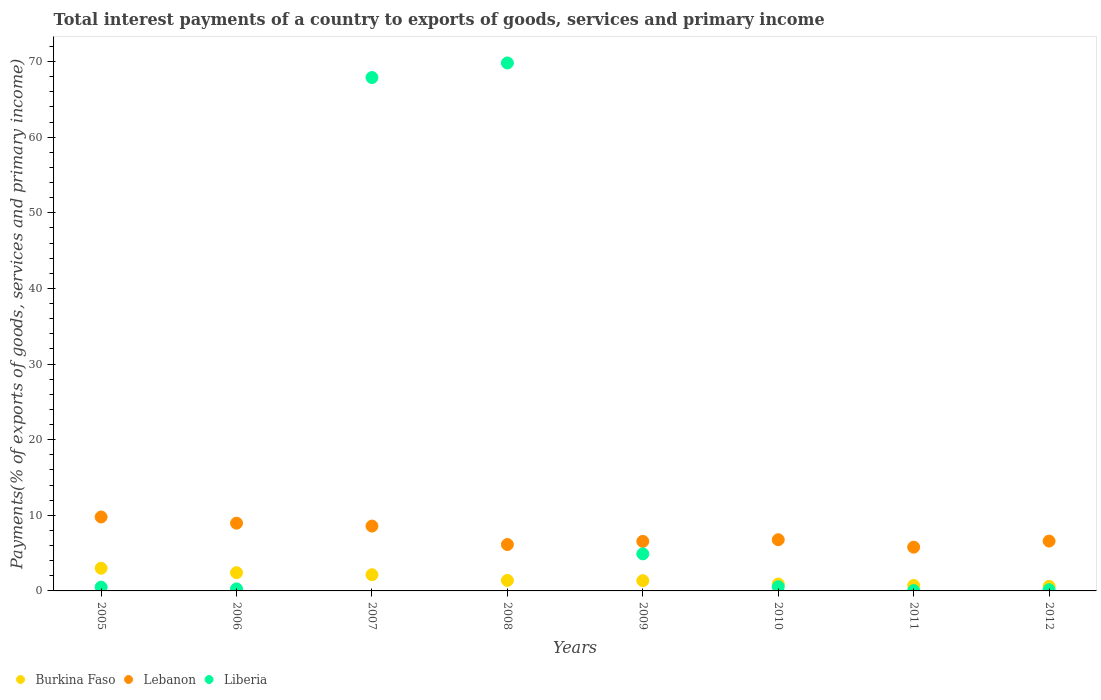How many different coloured dotlines are there?
Your answer should be very brief. 3. What is the total interest payments in Liberia in 2012?
Offer a terse response. 0.16. Across all years, what is the maximum total interest payments in Liberia?
Keep it short and to the point. 69.81. Across all years, what is the minimum total interest payments in Burkina Faso?
Make the answer very short. 0.6. In which year was the total interest payments in Liberia maximum?
Provide a succinct answer. 2008. In which year was the total interest payments in Lebanon minimum?
Ensure brevity in your answer.  2011. What is the total total interest payments in Lebanon in the graph?
Give a very brief answer. 59.14. What is the difference between the total interest payments in Liberia in 2007 and that in 2011?
Keep it short and to the point. 67.84. What is the difference between the total interest payments in Burkina Faso in 2006 and the total interest payments in Lebanon in 2005?
Your response must be concise. -7.37. What is the average total interest payments in Liberia per year?
Keep it short and to the point. 18.02. In the year 2005, what is the difference between the total interest payments in Lebanon and total interest payments in Liberia?
Ensure brevity in your answer.  9.27. In how many years, is the total interest payments in Lebanon greater than 50 %?
Ensure brevity in your answer.  0. What is the ratio of the total interest payments in Liberia in 2006 to that in 2009?
Your answer should be compact. 0.05. Is the total interest payments in Liberia in 2005 less than that in 2011?
Your response must be concise. No. Is the difference between the total interest payments in Lebanon in 2006 and 2008 greater than the difference between the total interest payments in Liberia in 2006 and 2008?
Offer a terse response. Yes. What is the difference between the highest and the second highest total interest payments in Liberia?
Ensure brevity in your answer.  1.93. What is the difference between the highest and the lowest total interest payments in Lebanon?
Your response must be concise. 3.99. In how many years, is the total interest payments in Liberia greater than the average total interest payments in Liberia taken over all years?
Give a very brief answer. 2. Is the sum of the total interest payments in Burkina Faso in 2010 and 2012 greater than the maximum total interest payments in Liberia across all years?
Provide a short and direct response. No. Does the total interest payments in Lebanon monotonically increase over the years?
Offer a terse response. No. Is the total interest payments in Liberia strictly greater than the total interest payments in Lebanon over the years?
Make the answer very short. No. How many years are there in the graph?
Offer a very short reply. 8. What is the difference between two consecutive major ticks on the Y-axis?
Ensure brevity in your answer.  10. Are the values on the major ticks of Y-axis written in scientific E-notation?
Your answer should be very brief. No. Where does the legend appear in the graph?
Your response must be concise. Bottom left. What is the title of the graph?
Provide a succinct answer. Total interest payments of a country to exports of goods, services and primary income. What is the label or title of the X-axis?
Your response must be concise. Years. What is the label or title of the Y-axis?
Provide a succinct answer. Payments(% of exports of goods, services and primary income). What is the Payments(% of exports of goods, services and primary income) of Burkina Faso in 2005?
Offer a very short reply. 3. What is the Payments(% of exports of goods, services and primary income) in Lebanon in 2005?
Your answer should be very brief. 9.78. What is the Payments(% of exports of goods, services and primary income) in Liberia in 2005?
Your answer should be compact. 0.5. What is the Payments(% of exports of goods, services and primary income) of Burkina Faso in 2006?
Your answer should be compact. 2.41. What is the Payments(% of exports of goods, services and primary income) in Lebanon in 2006?
Provide a short and direct response. 8.96. What is the Payments(% of exports of goods, services and primary income) of Liberia in 2006?
Provide a succinct answer. 0.27. What is the Payments(% of exports of goods, services and primary income) of Burkina Faso in 2007?
Keep it short and to the point. 2.14. What is the Payments(% of exports of goods, services and primary income) in Lebanon in 2007?
Offer a terse response. 8.58. What is the Payments(% of exports of goods, services and primary income) of Liberia in 2007?
Your answer should be compact. 67.89. What is the Payments(% of exports of goods, services and primary income) in Burkina Faso in 2008?
Keep it short and to the point. 1.39. What is the Payments(% of exports of goods, services and primary income) of Lebanon in 2008?
Make the answer very short. 6.13. What is the Payments(% of exports of goods, services and primary income) of Liberia in 2008?
Provide a short and direct response. 69.81. What is the Payments(% of exports of goods, services and primary income) of Burkina Faso in 2009?
Make the answer very short. 1.36. What is the Payments(% of exports of goods, services and primary income) of Lebanon in 2009?
Your answer should be very brief. 6.55. What is the Payments(% of exports of goods, services and primary income) in Liberia in 2009?
Keep it short and to the point. 4.9. What is the Payments(% of exports of goods, services and primary income) in Burkina Faso in 2010?
Your response must be concise. 0.91. What is the Payments(% of exports of goods, services and primary income) of Lebanon in 2010?
Offer a very short reply. 6.77. What is the Payments(% of exports of goods, services and primary income) of Liberia in 2010?
Your answer should be compact. 0.56. What is the Payments(% of exports of goods, services and primary income) of Burkina Faso in 2011?
Your response must be concise. 0.72. What is the Payments(% of exports of goods, services and primary income) in Lebanon in 2011?
Make the answer very short. 5.79. What is the Payments(% of exports of goods, services and primary income) in Liberia in 2011?
Provide a short and direct response. 0.05. What is the Payments(% of exports of goods, services and primary income) in Burkina Faso in 2012?
Your answer should be very brief. 0.6. What is the Payments(% of exports of goods, services and primary income) of Lebanon in 2012?
Keep it short and to the point. 6.59. What is the Payments(% of exports of goods, services and primary income) of Liberia in 2012?
Your answer should be very brief. 0.16. Across all years, what is the maximum Payments(% of exports of goods, services and primary income) in Burkina Faso?
Make the answer very short. 3. Across all years, what is the maximum Payments(% of exports of goods, services and primary income) of Lebanon?
Your answer should be compact. 9.78. Across all years, what is the maximum Payments(% of exports of goods, services and primary income) in Liberia?
Give a very brief answer. 69.81. Across all years, what is the minimum Payments(% of exports of goods, services and primary income) in Burkina Faso?
Provide a succinct answer. 0.6. Across all years, what is the minimum Payments(% of exports of goods, services and primary income) of Lebanon?
Your response must be concise. 5.79. Across all years, what is the minimum Payments(% of exports of goods, services and primary income) in Liberia?
Your answer should be compact. 0.05. What is the total Payments(% of exports of goods, services and primary income) in Burkina Faso in the graph?
Offer a very short reply. 12.53. What is the total Payments(% of exports of goods, services and primary income) in Lebanon in the graph?
Provide a short and direct response. 59.14. What is the total Payments(% of exports of goods, services and primary income) of Liberia in the graph?
Keep it short and to the point. 144.14. What is the difference between the Payments(% of exports of goods, services and primary income) in Burkina Faso in 2005 and that in 2006?
Ensure brevity in your answer.  0.59. What is the difference between the Payments(% of exports of goods, services and primary income) of Lebanon in 2005 and that in 2006?
Give a very brief answer. 0.82. What is the difference between the Payments(% of exports of goods, services and primary income) of Liberia in 2005 and that in 2006?
Your response must be concise. 0.24. What is the difference between the Payments(% of exports of goods, services and primary income) in Burkina Faso in 2005 and that in 2007?
Your response must be concise. 0.86. What is the difference between the Payments(% of exports of goods, services and primary income) of Lebanon in 2005 and that in 2007?
Your answer should be compact. 1.2. What is the difference between the Payments(% of exports of goods, services and primary income) in Liberia in 2005 and that in 2007?
Your response must be concise. -67.38. What is the difference between the Payments(% of exports of goods, services and primary income) in Burkina Faso in 2005 and that in 2008?
Your answer should be compact. 1.61. What is the difference between the Payments(% of exports of goods, services and primary income) of Lebanon in 2005 and that in 2008?
Your answer should be very brief. 3.64. What is the difference between the Payments(% of exports of goods, services and primary income) of Liberia in 2005 and that in 2008?
Ensure brevity in your answer.  -69.31. What is the difference between the Payments(% of exports of goods, services and primary income) in Burkina Faso in 2005 and that in 2009?
Your answer should be compact. 1.64. What is the difference between the Payments(% of exports of goods, services and primary income) in Lebanon in 2005 and that in 2009?
Offer a terse response. 3.23. What is the difference between the Payments(% of exports of goods, services and primary income) in Liberia in 2005 and that in 2009?
Offer a terse response. -4.4. What is the difference between the Payments(% of exports of goods, services and primary income) in Burkina Faso in 2005 and that in 2010?
Make the answer very short. 2.09. What is the difference between the Payments(% of exports of goods, services and primary income) in Lebanon in 2005 and that in 2010?
Your response must be concise. 3.01. What is the difference between the Payments(% of exports of goods, services and primary income) of Liberia in 2005 and that in 2010?
Make the answer very short. -0.06. What is the difference between the Payments(% of exports of goods, services and primary income) of Burkina Faso in 2005 and that in 2011?
Offer a terse response. 2.28. What is the difference between the Payments(% of exports of goods, services and primary income) in Lebanon in 2005 and that in 2011?
Keep it short and to the point. 3.99. What is the difference between the Payments(% of exports of goods, services and primary income) of Liberia in 2005 and that in 2011?
Your response must be concise. 0.45. What is the difference between the Payments(% of exports of goods, services and primary income) in Burkina Faso in 2005 and that in 2012?
Your answer should be very brief. 2.4. What is the difference between the Payments(% of exports of goods, services and primary income) of Lebanon in 2005 and that in 2012?
Your answer should be compact. 3.19. What is the difference between the Payments(% of exports of goods, services and primary income) of Liberia in 2005 and that in 2012?
Provide a succinct answer. 0.34. What is the difference between the Payments(% of exports of goods, services and primary income) in Burkina Faso in 2006 and that in 2007?
Your answer should be very brief. 0.27. What is the difference between the Payments(% of exports of goods, services and primary income) in Lebanon in 2006 and that in 2007?
Your response must be concise. 0.38. What is the difference between the Payments(% of exports of goods, services and primary income) in Liberia in 2006 and that in 2007?
Your answer should be compact. -67.62. What is the difference between the Payments(% of exports of goods, services and primary income) of Burkina Faso in 2006 and that in 2008?
Keep it short and to the point. 1.02. What is the difference between the Payments(% of exports of goods, services and primary income) of Lebanon in 2006 and that in 2008?
Your answer should be compact. 2.82. What is the difference between the Payments(% of exports of goods, services and primary income) in Liberia in 2006 and that in 2008?
Your response must be concise. -69.55. What is the difference between the Payments(% of exports of goods, services and primary income) of Burkina Faso in 2006 and that in 2009?
Provide a short and direct response. 1.05. What is the difference between the Payments(% of exports of goods, services and primary income) in Lebanon in 2006 and that in 2009?
Ensure brevity in your answer.  2.41. What is the difference between the Payments(% of exports of goods, services and primary income) of Liberia in 2006 and that in 2009?
Offer a terse response. -4.63. What is the difference between the Payments(% of exports of goods, services and primary income) of Burkina Faso in 2006 and that in 2010?
Make the answer very short. 1.5. What is the difference between the Payments(% of exports of goods, services and primary income) in Lebanon in 2006 and that in 2010?
Keep it short and to the point. 2.19. What is the difference between the Payments(% of exports of goods, services and primary income) in Liberia in 2006 and that in 2010?
Ensure brevity in your answer.  -0.29. What is the difference between the Payments(% of exports of goods, services and primary income) of Burkina Faso in 2006 and that in 2011?
Your answer should be very brief. 1.69. What is the difference between the Payments(% of exports of goods, services and primary income) of Lebanon in 2006 and that in 2011?
Provide a succinct answer. 3.17. What is the difference between the Payments(% of exports of goods, services and primary income) in Liberia in 2006 and that in 2011?
Your answer should be very brief. 0.22. What is the difference between the Payments(% of exports of goods, services and primary income) in Burkina Faso in 2006 and that in 2012?
Ensure brevity in your answer.  1.81. What is the difference between the Payments(% of exports of goods, services and primary income) of Lebanon in 2006 and that in 2012?
Ensure brevity in your answer.  2.37. What is the difference between the Payments(% of exports of goods, services and primary income) of Liberia in 2006 and that in 2012?
Offer a very short reply. 0.11. What is the difference between the Payments(% of exports of goods, services and primary income) of Burkina Faso in 2007 and that in 2008?
Give a very brief answer. 0.75. What is the difference between the Payments(% of exports of goods, services and primary income) of Lebanon in 2007 and that in 2008?
Provide a succinct answer. 2.44. What is the difference between the Payments(% of exports of goods, services and primary income) in Liberia in 2007 and that in 2008?
Your response must be concise. -1.93. What is the difference between the Payments(% of exports of goods, services and primary income) of Burkina Faso in 2007 and that in 2009?
Give a very brief answer. 0.78. What is the difference between the Payments(% of exports of goods, services and primary income) in Lebanon in 2007 and that in 2009?
Make the answer very short. 2.02. What is the difference between the Payments(% of exports of goods, services and primary income) in Liberia in 2007 and that in 2009?
Offer a terse response. 62.99. What is the difference between the Payments(% of exports of goods, services and primary income) in Burkina Faso in 2007 and that in 2010?
Offer a terse response. 1.23. What is the difference between the Payments(% of exports of goods, services and primary income) in Lebanon in 2007 and that in 2010?
Keep it short and to the point. 1.81. What is the difference between the Payments(% of exports of goods, services and primary income) of Liberia in 2007 and that in 2010?
Keep it short and to the point. 67.33. What is the difference between the Payments(% of exports of goods, services and primary income) in Burkina Faso in 2007 and that in 2011?
Keep it short and to the point. 1.42. What is the difference between the Payments(% of exports of goods, services and primary income) in Lebanon in 2007 and that in 2011?
Your response must be concise. 2.79. What is the difference between the Payments(% of exports of goods, services and primary income) in Liberia in 2007 and that in 2011?
Ensure brevity in your answer.  67.84. What is the difference between the Payments(% of exports of goods, services and primary income) of Burkina Faso in 2007 and that in 2012?
Make the answer very short. 1.54. What is the difference between the Payments(% of exports of goods, services and primary income) in Lebanon in 2007 and that in 2012?
Your answer should be compact. 1.99. What is the difference between the Payments(% of exports of goods, services and primary income) in Liberia in 2007 and that in 2012?
Keep it short and to the point. 67.73. What is the difference between the Payments(% of exports of goods, services and primary income) in Burkina Faso in 2008 and that in 2009?
Provide a succinct answer. 0.03. What is the difference between the Payments(% of exports of goods, services and primary income) in Lebanon in 2008 and that in 2009?
Provide a succinct answer. -0.42. What is the difference between the Payments(% of exports of goods, services and primary income) in Liberia in 2008 and that in 2009?
Your response must be concise. 64.91. What is the difference between the Payments(% of exports of goods, services and primary income) of Burkina Faso in 2008 and that in 2010?
Ensure brevity in your answer.  0.47. What is the difference between the Payments(% of exports of goods, services and primary income) in Lebanon in 2008 and that in 2010?
Offer a very short reply. -0.64. What is the difference between the Payments(% of exports of goods, services and primary income) in Liberia in 2008 and that in 2010?
Provide a succinct answer. 69.26. What is the difference between the Payments(% of exports of goods, services and primary income) in Burkina Faso in 2008 and that in 2011?
Your answer should be compact. 0.67. What is the difference between the Payments(% of exports of goods, services and primary income) in Lebanon in 2008 and that in 2011?
Make the answer very short. 0.35. What is the difference between the Payments(% of exports of goods, services and primary income) in Liberia in 2008 and that in 2011?
Provide a short and direct response. 69.77. What is the difference between the Payments(% of exports of goods, services and primary income) of Burkina Faso in 2008 and that in 2012?
Provide a short and direct response. 0.78. What is the difference between the Payments(% of exports of goods, services and primary income) in Lebanon in 2008 and that in 2012?
Provide a short and direct response. -0.46. What is the difference between the Payments(% of exports of goods, services and primary income) of Liberia in 2008 and that in 2012?
Offer a very short reply. 69.65. What is the difference between the Payments(% of exports of goods, services and primary income) of Burkina Faso in 2009 and that in 2010?
Give a very brief answer. 0.45. What is the difference between the Payments(% of exports of goods, services and primary income) of Lebanon in 2009 and that in 2010?
Provide a short and direct response. -0.22. What is the difference between the Payments(% of exports of goods, services and primary income) of Liberia in 2009 and that in 2010?
Offer a terse response. 4.34. What is the difference between the Payments(% of exports of goods, services and primary income) in Burkina Faso in 2009 and that in 2011?
Your answer should be very brief. 0.64. What is the difference between the Payments(% of exports of goods, services and primary income) of Lebanon in 2009 and that in 2011?
Your response must be concise. 0.76. What is the difference between the Payments(% of exports of goods, services and primary income) in Liberia in 2009 and that in 2011?
Ensure brevity in your answer.  4.85. What is the difference between the Payments(% of exports of goods, services and primary income) of Burkina Faso in 2009 and that in 2012?
Keep it short and to the point. 0.76. What is the difference between the Payments(% of exports of goods, services and primary income) of Lebanon in 2009 and that in 2012?
Offer a very short reply. -0.04. What is the difference between the Payments(% of exports of goods, services and primary income) of Liberia in 2009 and that in 2012?
Your answer should be compact. 4.74. What is the difference between the Payments(% of exports of goods, services and primary income) of Burkina Faso in 2010 and that in 2011?
Keep it short and to the point. 0.19. What is the difference between the Payments(% of exports of goods, services and primary income) in Lebanon in 2010 and that in 2011?
Keep it short and to the point. 0.98. What is the difference between the Payments(% of exports of goods, services and primary income) of Liberia in 2010 and that in 2011?
Your answer should be compact. 0.51. What is the difference between the Payments(% of exports of goods, services and primary income) of Burkina Faso in 2010 and that in 2012?
Your answer should be very brief. 0.31. What is the difference between the Payments(% of exports of goods, services and primary income) of Lebanon in 2010 and that in 2012?
Keep it short and to the point. 0.18. What is the difference between the Payments(% of exports of goods, services and primary income) of Liberia in 2010 and that in 2012?
Your answer should be very brief. 0.4. What is the difference between the Payments(% of exports of goods, services and primary income) of Burkina Faso in 2011 and that in 2012?
Keep it short and to the point. 0.12. What is the difference between the Payments(% of exports of goods, services and primary income) in Lebanon in 2011 and that in 2012?
Provide a succinct answer. -0.8. What is the difference between the Payments(% of exports of goods, services and primary income) in Liberia in 2011 and that in 2012?
Offer a terse response. -0.11. What is the difference between the Payments(% of exports of goods, services and primary income) of Burkina Faso in 2005 and the Payments(% of exports of goods, services and primary income) of Lebanon in 2006?
Your answer should be very brief. -5.96. What is the difference between the Payments(% of exports of goods, services and primary income) in Burkina Faso in 2005 and the Payments(% of exports of goods, services and primary income) in Liberia in 2006?
Keep it short and to the point. 2.73. What is the difference between the Payments(% of exports of goods, services and primary income) in Lebanon in 2005 and the Payments(% of exports of goods, services and primary income) in Liberia in 2006?
Keep it short and to the point. 9.51. What is the difference between the Payments(% of exports of goods, services and primary income) in Burkina Faso in 2005 and the Payments(% of exports of goods, services and primary income) in Lebanon in 2007?
Your response must be concise. -5.58. What is the difference between the Payments(% of exports of goods, services and primary income) in Burkina Faso in 2005 and the Payments(% of exports of goods, services and primary income) in Liberia in 2007?
Make the answer very short. -64.89. What is the difference between the Payments(% of exports of goods, services and primary income) in Lebanon in 2005 and the Payments(% of exports of goods, services and primary income) in Liberia in 2007?
Your answer should be compact. -58.11. What is the difference between the Payments(% of exports of goods, services and primary income) of Burkina Faso in 2005 and the Payments(% of exports of goods, services and primary income) of Lebanon in 2008?
Your answer should be compact. -3.13. What is the difference between the Payments(% of exports of goods, services and primary income) of Burkina Faso in 2005 and the Payments(% of exports of goods, services and primary income) of Liberia in 2008?
Ensure brevity in your answer.  -66.81. What is the difference between the Payments(% of exports of goods, services and primary income) in Lebanon in 2005 and the Payments(% of exports of goods, services and primary income) in Liberia in 2008?
Make the answer very short. -60.04. What is the difference between the Payments(% of exports of goods, services and primary income) in Burkina Faso in 2005 and the Payments(% of exports of goods, services and primary income) in Lebanon in 2009?
Your response must be concise. -3.55. What is the difference between the Payments(% of exports of goods, services and primary income) in Burkina Faso in 2005 and the Payments(% of exports of goods, services and primary income) in Liberia in 2009?
Your answer should be compact. -1.9. What is the difference between the Payments(% of exports of goods, services and primary income) in Lebanon in 2005 and the Payments(% of exports of goods, services and primary income) in Liberia in 2009?
Keep it short and to the point. 4.88. What is the difference between the Payments(% of exports of goods, services and primary income) of Burkina Faso in 2005 and the Payments(% of exports of goods, services and primary income) of Lebanon in 2010?
Give a very brief answer. -3.77. What is the difference between the Payments(% of exports of goods, services and primary income) in Burkina Faso in 2005 and the Payments(% of exports of goods, services and primary income) in Liberia in 2010?
Your answer should be very brief. 2.44. What is the difference between the Payments(% of exports of goods, services and primary income) of Lebanon in 2005 and the Payments(% of exports of goods, services and primary income) of Liberia in 2010?
Keep it short and to the point. 9.22. What is the difference between the Payments(% of exports of goods, services and primary income) of Burkina Faso in 2005 and the Payments(% of exports of goods, services and primary income) of Lebanon in 2011?
Keep it short and to the point. -2.79. What is the difference between the Payments(% of exports of goods, services and primary income) of Burkina Faso in 2005 and the Payments(% of exports of goods, services and primary income) of Liberia in 2011?
Your answer should be compact. 2.95. What is the difference between the Payments(% of exports of goods, services and primary income) in Lebanon in 2005 and the Payments(% of exports of goods, services and primary income) in Liberia in 2011?
Offer a terse response. 9.73. What is the difference between the Payments(% of exports of goods, services and primary income) of Burkina Faso in 2005 and the Payments(% of exports of goods, services and primary income) of Lebanon in 2012?
Offer a terse response. -3.59. What is the difference between the Payments(% of exports of goods, services and primary income) of Burkina Faso in 2005 and the Payments(% of exports of goods, services and primary income) of Liberia in 2012?
Give a very brief answer. 2.84. What is the difference between the Payments(% of exports of goods, services and primary income) in Lebanon in 2005 and the Payments(% of exports of goods, services and primary income) in Liberia in 2012?
Your answer should be compact. 9.62. What is the difference between the Payments(% of exports of goods, services and primary income) in Burkina Faso in 2006 and the Payments(% of exports of goods, services and primary income) in Lebanon in 2007?
Make the answer very short. -6.17. What is the difference between the Payments(% of exports of goods, services and primary income) of Burkina Faso in 2006 and the Payments(% of exports of goods, services and primary income) of Liberia in 2007?
Offer a terse response. -65.48. What is the difference between the Payments(% of exports of goods, services and primary income) in Lebanon in 2006 and the Payments(% of exports of goods, services and primary income) in Liberia in 2007?
Your answer should be very brief. -58.93. What is the difference between the Payments(% of exports of goods, services and primary income) of Burkina Faso in 2006 and the Payments(% of exports of goods, services and primary income) of Lebanon in 2008?
Ensure brevity in your answer.  -3.72. What is the difference between the Payments(% of exports of goods, services and primary income) of Burkina Faso in 2006 and the Payments(% of exports of goods, services and primary income) of Liberia in 2008?
Provide a short and direct response. -67.4. What is the difference between the Payments(% of exports of goods, services and primary income) of Lebanon in 2006 and the Payments(% of exports of goods, services and primary income) of Liberia in 2008?
Make the answer very short. -60.86. What is the difference between the Payments(% of exports of goods, services and primary income) of Burkina Faso in 2006 and the Payments(% of exports of goods, services and primary income) of Lebanon in 2009?
Keep it short and to the point. -4.14. What is the difference between the Payments(% of exports of goods, services and primary income) in Burkina Faso in 2006 and the Payments(% of exports of goods, services and primary income) in Liberia in 2009?
Your response must be concise. -2.49. What is the difference between the Payments(% of exports of goods, services and primary income) of Lebanon in 2006 and the Payments(% of exports of goods, services and primary income) of Liberia in 2009?
Provide a succinct answer. 4.06. What is the difference between the Payments(% of exports of goods, services and primary income) in Burkina Faso in 2006 and the Payments(% of exports of goods, services and primary income) in Lebanon in 2010?
Offer a very short reply. -4.36. What is the difference between the Payments(% of exports of goods, services and primary income) of Burkina Faso in 2006 and the Payments(% of exports of goods, services and primary income) of Liberia in 2010?
Ensure brevity in your answer.  1.85. What is the difference between the Payments(% of exports of goods, services and primary income) in Lebanon in 2006 and the Payments(% of exports of goods, services and primary income) in Liberia in 2010?
Offer a very short reply. 8.4. What is the difference between the Payments(% of exports of goods, services and primary income) in Burkina Faso in 2006 and the Payments(% of exports of goods, services and primary income) in Lebanon in 2011?
Provide a short and direct response. -3.38. What is the difference between the Payments(% of exports of goods, services and primary income) in Burkina Faso in 2006 and the Payments(% of exports of goods, services and primary income) in Liberia in 2011?
Provide a short and direct response. 2.36. What is the difference between the Payments(% of exports of goods, services and primary income) of Lebanon in 2006 and the Payments(% of exports of goods, services and primary income) of Liberia in 2011?
Ensure brevity in your answer.  8.91. What is the difference between the Payments(% of exports of goods, services and primary income) of Burkina Faso in 2006 and the Payments(% of exports of goods, services and primary income) of Lebanon in 2012?
Ensure brevity in your answer.  -4.18. What is the difference between the Payments(% of exports of goods, services and primary income) in Burkina Faso in 2006 and the Payments(% of exports of goods, services and primary income) in Liberia in 2012?
Provide a short and direct response. 2.25. What is the difference between the Payments(% of exports of goods, services and primary income) in Lebanon in 2006 and the Payments(% of exports of goods, services and primary income) in Liberia in 2012?
Ensure brevity in your answer.  8.8. What is the difference between the Payments(% of exports of goods, services and primary income) in Burkina Faso in 2007 and the Payments(% of exports of goods, services and primary income) in Lebanon in 2008?
Ensure brevity in your answer.  -3.99. What is the difference between the Payments(% of exports of goods, services and primary income) of Burkina Faso in 2007 and the Payments(% of exports of goods, services and primary income) of Liberia in 2008?
Your answer should be compact. -67.67. What is the difference between the Payments(% of exports of goods, services and primary income) in Lebanon in 2007 and the Payments(% of exports of goods, services and primary income) in Liberia in 2008?
Your response must be concise. -61.24. What is the difference between the Payments(% of exports of goods, services and primary income) of Burkina Faso in 2007 and the Payments(% of exports of goods, services and primary income) of Lebanon in 2009?
Your response must be concise. -4.41. What is the difference between the Payments(% of exports of goods, services and primary income) of Burkina Faso in 2007 and the Payments(% of exports of goods, services and primary income) of Liberia in 2009?
Keep it short and to the point. -2.76. What is the difference between the Payments(% of exports of goods, services and primary income) in Lebanon in 2007 and the Payments(% of exports of goods, services and primary income) in Liberia in 2009?
Provide a succinct answer. 3.68. What is the difference between the Payments(% of exports of goods, services and primary income) of Burkina Faso in 2007 and the Payments(% of exports of goods, services and primary income) of Lebanon in 2010?
Give a very brief answer. -4.63. What is the difference between the Payments(% of exports of goods, services and primary income) in Burkina Faso in 2007 and the Payments(% of exports of goods, services and primary income) in Liberia in 2010?
Your answer should be very brief. 1.58. What is the difference between the Payments(% of exports of goods, services and primary income) in Lebanon in 2007 and the Payments(% of exports of goods, services and primary income) in Liberia in 2010?
Your answer should be compact. 8.02. What is the difference between the Payments(% of exports of goods, services and primary income) of Burkina Faso in 2007 and the Payments(% of exports of goods, services and primary income) of Lebanon in 2011?
Ensure brevity in your answer.  -3.65. What is the difference between the Payments(% of exports of goods, services and primary income) in Burkina Faso in 2007 and the Payments(% of exports of goods, services and primary income) in Liberia in 2011?
Keep it short and to the point. 2.09. What is the difference between the Payments(% of exports of goods, services and primary income) of Lebanon in 2007 and the Payments(% of exports of goods, services and primary income) of Liberia in 2011?
Keep it short and to the point. 8.53. What is the difference between the Payments(% of exports of goods, services and primary income) in Burkina Faso in 2007 and the Payments(% of exports of goods, services and primary income) in Lebanon in 2012?
Make the answer very short. -4.45. What is the difference between the Payments(% of exports of goods, services and primary income) of Burkina Faso in 2007 and the Payments(% of exports of goods, services and primary income) of Liberia in 2012?
Provide a succinct answer. 1.98. What is the difference between the Payments(% of exports of goods, services and primary income) in Lebanon in 2007 and the Payments(% of exports of goods, services and primary income) in Liberia in 2012?
Offer a terse response. 8.42. What is the difference between the Payments(% of exports of goods, services and primary income) in Burkina Faso in 2008 and the Payments(% of exports of goods, services and primary income) in Lebanon in 2009?
Your answer should be compact. -5.17. What is the difference between the Payments(% of exports of goods, services and primary income) of Burkina Faso in 2008 and the Payments(% of exports of goods, services and primary income) of Liberia in 2009?
Provide a short and direct response. -3.51. What is the difference between the Payments(% of exports of goods, services and primary income) of Lebanon in 2008 and the Payments(% of exports of goods, services and primary income) of Liberia in 2009?
Offer a very short reply. 1.23. What is the difference between the Payments(% of exports of goods, services and primary income) of Burkina Faso in 2008 and the Payments(% of exports of goods, services and primary income) of Lebanon in 2010?
Offer a terse response. -5.38. What is the difference between the Payments(% of exports of goods, services and primary income) of Burkina Faso in 2008 and the Payments(% of exports of goods, services and primary income) of Liberia in 2010?
Ensure brevity in your answer.  0.83. What is the difference between the Payments(% of exports of goods, services and primary income) in Lebanon in 2008 and the Payments(% of exports of goods, services and primary income) in Liberia in 2010?
Provide a short and direct response. 5.58. What is the difference between the Payments(% of exports of goods, services and primary income) of Burkina Faso in 2008 and the Payments(% of exports of goods, services and primary income) of Lebanon in 2011?
Keep it short and to the point. -4.4. What is the difference between the Payments(% of exports of goods, services and primary income) in Burkina Faso in 2008 and the Payments(% of exports of goods, services and primary income) in Liberia in 2011?
Keep it short and to the point. 1.34. What is the difference between the Payments(% of exports of goods, services and primary income) of Lebanon in 2008 and the Payments(% of exports of goods, services and primary income) of Liberia in 2011?
Your answer should be compact. 6.08. What is the difference between the Payments(% of exports of goods, services and primary income) in Burkina Faso in 2008 and the Payments(% of exports of goods, services and primary income) in Lebanon in 2012?
Provide a succinct answer. -5.2. What is the difference between the Payments(% of exports of goods, services and primary income) of Burkina Faso in 2008 and the Payments(% of exports of goods, services and primary income) of Liberia in 2012?
Give a very brief answer. 1.23. What is the difference between the Payments(% of exports of goods, services and primary income) of Lebanon in 2008 and the Payments(% of exports of goods, services and primary income) of Liberia in 2012?
Ensure brevity in your answer.  5.97. What is the difference between the Payments(% of exports of goods, services and primary income) in Burkina Faso in 2009 and the Payments(% of exports of goods, services and primary income) in Lebanon in 2010?
Give a very brief answer. -5.41. What is the difference between the Payments(% of exports of goods, services and primary income) of Burkina Faso in 2009 and the Payments(% of exports of goods, services and primary income) of Liberia in 2010?
Your answer should be compact. 0.8. What is the difference between the Payments(% of exports of goods, services and primary income) of Lebanon in 2009 and the Payments(% of exports of goods, services and primary income) of Liberia in 2010?
Keep it short and to the point. 5.99. What is the difference between the Payments(% of exports of goods, services and primary income) of Burkina Faso in 2009 and the Payments(% of exports of goods, services and primary income) of Lebanon in 2011?
Keep it short and to the point. -4.43. What is the difference between the Payments(% of exports of goods, services and primary income) in Burkina Faso in 2009 and the Payments(% of exports of goods, services and primary income) in Liberia in 2011?
Make the answer very short. 1.31. What is the difference between the Payments(% of exports of goods, services and primary income) of Lebanon in 2009 and the Payments(% of exports of goods, services and primary income) of Liberia in 2011?
Provide a succinct answer. 6.5. What is the difference between the Payments(% of exports of goods, services and primary income) of Burkina Faso in 2009 and the Payments(% of exports of goods, services and primary income) of Lebanon in 2012?
Offer a terse response. -5.23. What is the difference between the Payments(% of exports of goods, services and primary income) in Burkina Faso in 2009 and the Payments(% of exports of goods, services and primary income) in Liberia in 2012?
Make the answer very short. 1.2. What is the difference between the Payments(% of exports of goods, services and primary income) in Lebanon in 2009 and the Payments(% of exports of goods, services and primary income) in Liberia in 2012?
Offer a very short reply. 6.39. What is the difference between the Payments(% of exports of goods, services and primary income) in Burkina Faso in 2010 and the Payments(% of exports of goods, services and primary income) in Lebanon in 2011?
Offer a terse response. -4.87. What is the difference between the Payments(% of exports of goods, services and primary income) of Burkina Faso in 2010 and the Payments(% of exports of goods, services and primary income) of Liberia in 2011?
Your response must be concise. 0.86. What is the difference between the Payments(% of exports of goods, services and primary income) of Lebanon in 2010 and the Payments(% of exports of goods, services and primary income) of Liberia in 2011?
Provide a succinct answer. 6.72. What is the difference between the Payments(% of exports of goods, services and primary income) in Burkina Faso in 2010 and the Payments(% of exports of goods, services and primary income) in Lebanon in 2012?
Your answer should be very brief. -5.68. What is the difference between the Payments(% of exports of goods, services and primary income) in Burkina Faso in 2010 and the Payments(% of exports of goods, services and primary income) in Liberia in 2012?
Offer a terse response. 0.75. What is the difference between the Payments(% of exports of goods, services and primary income) of Lebanon in 2010 and the Payments(% of exports of goods, services and primary income) of Liberia in 2012?
Keep it short and to the point. 6.61. What is the difference between the Payments(% of exports of goods, services and primary income) of Burkina Faso in 2011 and the Payments(% of exports of goods, services and primary income) of Lebanon in 2012?
Provide a short and direct response. -5.87. What is the difference between the Payments(% of exports of goods, services and primary income) of Burkina Faso in 2011 and the Payments(% of exports of goods, services and primary income) of Liberia in 2012?
Your answer should be compact. 0.56. What is the difference between the Payments(% of exports of goods, services and primary income) in Lebanon in 2011 and the Payments(% of exports of goods, services and primary income) in Liberia in 2012?
Make the answer very short. 5.63. What is the average Payments(% of exports of goods, services and primary income) of Burkina Faso per year?
Offer a terse response. 1.57. What is the average Payments(% of exports of goods, services and primary income) in Lebanon per year?
Provide a succinct answer. 7.39. What is the average Payments(% of exports of goods, services and primary income) of Liberia per year?
Ensure brevity in your answer.  18.02. In the year 2005, what is the difference between the Payments(% of exports of goods, services and primary income) in Burkina Faso and Payments(% of exports of goods, services and primary income) in Lebanon?
Your answer should be compact. -6.78. In the year 2005, what is the difference between the Payments(% of exports of goods, services and primary income) in Burkina Faso and Payments(% of exports of goods, services and primary income) in Liberia?
Provide a succinct answer. 2.5. In the year 2005, what is the difference between the Payments(% of exports of goods, services and primary income) of Lebanon and Payments(% of exports of goods, services and primary income) of Liberia?
Ensure brevity in your answer.  9.27. In the year 2006, what is the difference between the Payments(% of exports of goods, services and primary income) in Burkina Faso and Payments(% of exports of goods, services and primary income) in Lebanon?
Provide a short and direct response. -6.55. In the year 2006, what is the difference between the Payments(% of exports of goods, services and primary income) of Burkina Faso and Payments(% of exports of goods, services and primary income) of Liberia?
Offer a terse response. 2.14. In the year 2006, what is the difference between the Payments(% of exports of goods, services and primary income) of Lebanon and Payments(% of exports of goods, services and primary income) of Liberia?
Provide a succinct answer. 8.69. In the year 2007, what is the difference between the Payments(% of exports of goods, services and primary income) of Burkina Faso and Payments(% of exports of goods, services and primary income) of Lebanon?
Make the answer very short. -6.44. In the year 2007, what is the difference between the Payments(% of exports of goods, services and primary income) of Burkina Faso and Payments(% of exports of goods, services and primary income) of Liberia?
Your answer should be very brief. -65.75. In the year 2007, what is the difference between the Payments(% of exports of goods, services and primary income) of Lebanon and Payments(% of exports of goods, services and primary income) of Liberia?
Make the answer very short. -59.31. In the year 2008, what is the difference between the Payments(% of exports of goods, services and primary income) in Burkina Faso and Payments(% of exports of goods, services and primary income) in Lebanon?
Make the answer very short. -4.75. In the year 2008, what is the difference between the Payments(% of exports of goods, services and primary income) in Burkina Faso and Payments(% of exports of goods, services and primary income) in Liberia?
Keep it short and to the point. -68.43. In the year 2008, what is the difference between the Payments(% of exports of goods, services and primary income) in Lebanon and Payments(% of exports of goods, services and primary income) in Liberia?
Offer a terse response. -63.68. In the year 2009, what is the difference between the Payments(% of exports of goods, services and primary income) of Burkina Faso and Payments(% of exports of goods, services and primary income) of Lebanon?
Ensure brevity in your answer.  -5.19. In the year 2009, what is the difference between the Payments(% of exports of goods, services and primary income) of Burkina Faso and Payments(% of exports of goods, services and primary income) of Liberia?
Provide a short and direct response. -3.54. In the year 2009, what is the difference between the Payments(% of exports of goods, services and primary income) of Lebanon and Payments(% of exports of goods, services and primary income) of Liberia?
Your answer should be compact. 1.65. In the year 2010, what is the difference between the Payments(% of exports of goods, services and primary income) in Burkina Faso and Payments(% of exports of goods, services and primary income) in Lebanon?
Offer a very short reply. -5.86. In the year 2010, what is the difference between the Payments(% of exports of goods, services and primary income) in Burkina Faso and Payments(% of exports of goods, services and primary income) in Liberia?
Offer a terse response. 0.35. In the year 2010, what is the difference between the Payments(% of exports of goods, services and primary income) in Lebanon and Payments(% of exports of goods, services and primary income) in Liberia?
Provide a succinct answer. 6.21. In the year 2011, what is the difference between the Payments(% of exports of goods, services and primary income) of Burkina Faso and Payments(% of exports of goods, services and primary income) of Lebanon?
Your answer should be compact. -5.07. In the year 2011, what is the difference between the Payments(% of exports of goods, services and primary income) of Burkina Faso and Payments(% of exports of goods, services and primary income) of Liberia?
Your response must be concise. 0.67. In the year 2011, what is the difference between the Payments(% of exports of goods, services and primary income) in Lebanon and Payments(% of exports of goods, services and primary income) in Liberia?
Make the answer very short. 5.74. In the year 2012, what is the difference between the Payments(% of exports of goods, services and primary income) in Burkina Faso and Payments(% of exports of goods, services and primary income) in Lebanon?
Provide a succinct answer. -5.99. In the year 2012, what is the difference between the Payments(% of exports of goods, services and primary income) in Burkina Faso and Payments(% of exports of goods, services and primary income) in Liberia?
Offer a very short reply. 0.44. In the year 2012, what is the difference between the Payments(% of exports of goods, services and primary income) in Lebanon and Payments(% of exports of goods, services and primary income) in Liberia?
Make the answer very short. 6.43. What is the ratio of the Payments(% of exports of goods, services and primary income) of Burkina Faso in 2005 to that in 2006?
Give a very brief answer. 1.24. What is the ratio of the Payments(% of exports of goods, services and primary income) of Lebanon in 2005 to that in 2006?
Ensure brevity in your answer.  1.09. What is the ratio of the Payments(% of exports of goods, services and primary income) of Liberia in 2005 to that in 2006?
Give a very brief answer. 1.88. What is the ratio of the Payments(% of exports of goods, services and primary income) in Burkina Faso in 2005 to that in 2007?
Your answer should be very brief. 1.4. What is the ratio of the Payments(% of exports of goods, services and primary income) in Lebanon in 2005 to that in 2007?
Give a very brief answer. 1.14. What is the ratio of the Payments(% of exports of goods, services and primary income) of Liberia in 2005 to that in 2007?
Make the answer very short. 0.01. What is the ratio of the Payments(% of exports of goods, services and primary income) in Burkina Faso in 2005 to that in 2008?
Provide a short and direct response. 2.16. What is the ratio of the Payments(% of exports of goods, services and primary income) in Lebanon in 2005 to that in 2008?
Give a very brief answer. 1.59. What is the ratio of the Payments(% of exports of goods, services and primary income) in Liberia in 2005 to that in 2008?
Give a very brief answer. 0.01. What is the ratio of the Payments(% of exports of goods, services and primary income) in Burkina Faso in 2005 to that in 2009?
Give a very brief answer. 2.21. What is the ratio of the Payments(% of exports of goods, services and primary income) of Lebanon in 2005 to that in 2009?
Provide a succinct answer. 1.49. What is the ratio of the Payments(% of exports of goods, services and primary income) in Liberia in 2005 to that in 2009?
Provide a short and direct response. 0.1. What is the ratio of the Payments(% of exports of goods, services and primary income) in Burkina Faso in 2005 to that in 2010?
Provide a succinct answer. 3.29. What is the ratio of the Payments(% of exports of goods, services and primary income) in Lebanon in 2005 to that in 2010?
Offer a very short reply. 1.44. What is the ratio of the Payments(% of exports of goods, services and primary income) in Liberia in 2005 to that in 2010?
Give a very brief answer. 0.9. What is the ratio of the Payments(% of exports of goods, services and primary income) in Burkina Faso in 2005 to that in 2011?
Give a very brief answer. 4.17. What is the ratio of the Payments(% of exports of goods, services and primary income) in Lebanon in 2005 to that in 2011?
Offer a terse response. 1.69. What is the ratio of the Payments(% of exports of goods, services and primary income) of Liberia in 2005 to that in 2011?
Give a very brief answer. 10.35. What is the ratio of the Payments(% of exports of goods, services and primary income) of Burkina Faso in 2005 to that in 2012?
Your answer should be compact. 4.98. What is the ratio of the Payments(% of exports of goods, services and primary income) of Lebanon in 2005 to that in 2012?
Your answer should be compact. 1.48. What is the ratio of the Payments(% of exports of goods, services and primary income) in Liberia in 2005 to that in 2012?
Your response must be concise. 3.15. What is the ratio of the Payments(% of exports of goods, services and primary income) in Burkina Faso in 2006 to that in 2007?
Ensure brevity in your answer.  1.13. What is the ratio of the Payments(% of exports of goods, services and primary income) of Lebanon in 2006 to that in 2007?
Give a very brief answer. 1.04. What is the ratio of the Payments(% of exports of goods, services and primary income) of Liberia in 2006 to that in 2007?
Your answer should be very brief. 0. What is the ratio of the Payments(% of exports of goods, services and primary income) of Burkina Faso in 2006 to that in 2008?
Offer a terse response. 1.74. What is the ratio of the Payments(% of exports of goods, services and primary income) of Lebanon in 2006 to that in 2008?
Provide a short and direct response. 1.46. What is the ratio of the Payments(% of exports of goods, services and primary income) of Liberia in 2006 to that in 2008?
Keep it short and to the point. 0. What is the ratio of the Payments(% of exports of goods, services and primary income) of Burkina Faso in 2006 to that in 2009?
Provide a succinct answer. 1.77. What is the ratio of the Payments(% of exports of goods, services and primary income) of Lebanon in 2006 to that in 2009?
Keep it short and to the point. 1.37. What is the ratio of the Payments(% of exports of goods, services and primary income) of Liberia in 2006 to that in 2009?
Your response must be concise. 0.05. What is the ratio of the Payments(% of exports of goods, services and primary income) of Burkina Faso in 2006 to that in 2010?
Your answer should be compact. 2.64. What is the ratio of the Payments(% of exports of goods, services and primary income) of Lebanon in 2006 to that in 2010?
Your answer should be compact. 1.32. What is the ratio of the Payments(% of exports of goods, services and primary income) in Liberia in 2006 to that in 2010?
Offer a very short reply. 0.48. What is the ratio of the Payments(% of exports of goods, services and primary income) in Burkina Faso in 2006 to that in 2011?
Keep it short and to the point. 3.35. What is the ratio of the Payments(% of exports of goods, services and primary income) of Lebanon in 2006 to that in 2011?
Your response must be concise. 1.55. What is the ratio of the Payments(% of exports of goods, services and primary income) of Liberia in 2006 to that in 2011?
Make the answer very short. 5.5. What is the ratio of the Payments(% of exports of goods, services and primary income) in Burkina Faso in 2006 to that in 2012?
Your answer should be very brief. 4. What is the ratio of the Payments(% of exports of goods, services and primary income) in Lebanon in 2006 to that in 2012?
Give a very brief answer. 1.36. What is the ratio of the Payments(% of exports of goods, services and primary income) of Liberia in 2006 to that in 2012?
Your answer should be very brief. 1.67. What is the ratio of the Payments(% of exports of goods, services and primary income) in Burkina Faso in 2007 to that in 2008?
Your answer should be very brief. 1.54. What is the ratio of the Payments(% of exports of goods, services and primary income) in Lebanon in 2007 to that in 2008?
Your answer should be compact. 1.4. What is the ratio of the Payments(% of exports of goods, services and primary income) of Liberia in 2007 to that in 2008?
Offer a very short reply. 0.97. What is the ratio of the Payments(% of exports of goods, services and primary income) in Burkina Faso in 2007 to that in 2009?
Offer a terse response. 1.57. What is the ratio of the Payments(% of exports of goods, services and primary income) in Lebanon in 2007 to that in 2009?
Give a very brief answer. 1.31. What is the ratio of the Payments(% of exports of goods, services and primary income) in Liberia in 2007 to that in 2009?
Give a very brief answer. 13.85. What is the ratio of the Payments(% of exports of goods, services and primary income) of Burkina Faso in 2007 to that in 2010?
Provide a succinct answer. 2.35. What is the ratio of the Payments(% of exports of goods, services and primary income) of Lebanon in 2007 to that in 2010?
Provide a succinct answer. 1.27. What is the ratio of the Payments(% of exports of goods, services and primary income) of Liberia in 2007 to that in 2010?
Your answer should be compact. 121.7. What is the ratio of the Payments(% of exports of goods, services and primary income) in Burkina Faso in 2007 to that in 2011?
Provide a succinct answer. 2.97. What is the ratio of the Payments(% of exports of goods, services and primary income) in Lebanon in 2007 to that in 2011?
Make the answer very short. 1.48. What is the ratio of the Payments(% of exports of goods, services and primary income) of Liberia in 2007 to that in 2011?
Make the answer very short. 1398.93. What is the ratio of the Payments(% of exports of goods, services and primary income) in Burkina Faso in 2007 to that in 2012?
Provide a succinct answer. 3.55. What is the ratio of the Payments(% of exports of goods, services and primary income) of Lebanon in 2007 to that in 2012?
Your response must be concise. 1.3. What is the ratio of the Payments(% of exports of goods, services and primary income) of Liberia in 2007 to that in 2012?
Make the answer very short. 425.55. What is the ratio of the Payments(% of exports of goods, services and primary income) in Burkina Faso in 2008 to that in 2009?
Offer a terse response. 1.02. What is the ratio of the Payments(% of exports of goods, services and primary income) in Lebanon in 2008 to that in 2009?
Ensure brevity in your answer.  0.94. What is the ratio of the Payments(% of exports of goods, services and primary income) in Liberia in 2008 to that in 2009?
Offer a terse response. 14.25. What is the ratio of the Payments(% of exports of goods, services and primary income) in Burkina Faso in 2008 to that in 2010?
Provide a short and direct response. 1.52. What is the ratio of the Payments(% of exports of goods, services and primary income) of Lebanon in 2008 to that in 2010?
Your response must be concise. 0.91. What is the ratio of the Payments(% of exports of goods, services and primary income) in Liberia in 2008 to that in 2010?
Your answer should be compact. 125.16. What is the ratio of the Payments(% of exports of goods, services and primary income) of Burkina Faso in 2008 to that in 2011?
Your answer should be compact. 1.93. What is the ratio of the Payments(% of exports of goods, services and primary income) in Lebanon in 2008 to that in 2011?
Ensure brevity in your answer.  1.06. What is the ratio of the Payments(% of exports of goods, services and primary income) of Liberia in 2008 to that in 2011?
Offer a very short reply. 1438.64. What is the ratio of the Payments(% of exports of goods, services and primary income) in Burkina Faso in 2008 to that in 2012?
Provide a succinct answer. 2.3. What is the ratio of the Payments(% of exports of goods, services and primary income) of Lebanon in 2008 to that in 2012?
Keep it short and to the point. 0.93. What is the ratio of the Payments(% of exports of goods, services and primary income) of Liberia in 2008 to that in 2012?
Ensure brevity in your answer.  437.63. What is the ratio of the Payments(% of exports of goods, services and primary income) of Burkina Faso in 2009 to that in 2010?
Offer a very short reply. 1.49. What is the ratio of the Payments(% of exports of goods, services and primary income) in Liberia in 2009 to that in 2010?
Provide a succinct answer. 8.79. What is the ratio of the Payments(% of exports of goods, services and primary income) of Burkina Faso in 2009 to that in 2011?
Your response must be concise. 1.89. What is the ratio of the Payments(% of exports of goods, services and primary income) of Lebanon in 2009 to that in 2011?
Offer a terse response. 1.13. What is the ratio of the Payments(% of exports of goods, services and primary income) of Liberia in 2009 to that in 2011?
Offer a very short reply. 100.99. What is the ratio of the Payments(% of exports of goods, services and primary income) of Burkina Faso in 2009 to that in 2012?
Keep it short and to the point. 2.25. What is the ratio of the Payments(% of exports of goods, services and primary income) in Liberia in 2009 to that in 2012?
Your response must be concise. 30.72. What is the ratio of the Payments(% of exports of goods, services and primary income) of Burkina Faso in 2010 to that in 2011?
Ensure brevity in your answer.  1.27. What is the ratio of the Payments(% of exports of goods, services and primary income) of Lebanon in 2010 to that in 2011?
Your response must be concise. 1.17. What is the ratio of the Payments(% of exports of goods, services and primary income) of Liberia in 2010 to that in 2011?
Ensure brevity in your answer.  11.49. What is the ratio of the Payments(% of exports of goods, services and primary income) in Burkina Faso in 2010 to that in 2012?
Offer a terse response. 1.51. What is the ratio of the Payments(% of exports of goods, services and primary income) in Lebanon in 2010 to that in 2012?
Offer a terse response. 1.03. What is the ratio of the Payments(% of exports of goods, services and primary income) of Liberia in 2010 to that in 2012?
Give a very brief answer. 3.5. What is the ratio of the Payments(% of exports of goods, services and primary income) of Burkina Faso in 2011 to that in 2012?
Provide a short and direct response. 1.19. What is the ratio of the Payments(% of exports of goods, services and primary income) of Lebanon in 2011 to that in 2012?
Your answer should be very brief. 0.88. What is the ratio of the Payments(% of exports of goods, services and primary income) of Liberia in 2011 to that in 2012?
Give a very brief answer. 0.3. What is the difference between the highest and the second highest Payments(% of exports of goods, services and primary income) in Burkina Faso?
Keep it short and to the point. 0.59. What is the difference between the highest and the second highest Payments(% of exports of goods, services and primary income) of Lebanon?
Make the answer very short. 0.82. What is the difference between the highest and the second highest Payments(% of exports of goods, services and primary income) in Liberia?
Offer a terse response. 1.93. What is the difference between the highest and the lowest Payments(% of exports of goods, services and primary income) of Burkina Faso?
Your response must be concise. 2.4. What is the difference between the highest and the lowest Payments(% of exports of goods, services and primary income) in Lebanon?
Give a very brief answer. 3.99. What is the difference between the highest and the lowest Payments(% of exports of goods, services and primary income) in Liberia?
Ensure brevity in your answer.  69.77. 